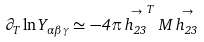Convert formula to latex. <formula><loc_0><loc_0><loc_500><loc_500>\partial _ { T } \ln Y _ { \alpha \beta \gamma } \simeq - 4 \pi \stackrel { \rightarrow } { h _ { 2 3 } } ^ { T } M \stackrel { \rightarrow } { h _ { 2 3 } }</formula> 